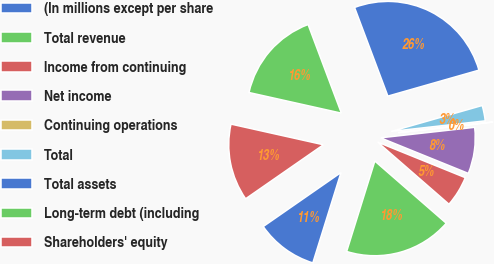Convert chart to OTSL. <chart><loc_0><loc_0><loc_500><loc_500><pie_chart><fcel>(In millions except per share<fcel>Total revenue<fcel>Income from continuing<fcel>Net income<fcel>Continuing operations<fcel>Total<fcel>Total assets<fcel>Long-term debt (including<fcel>Shareholders' equity<nl><fcel>10.53%<fcel>18.41%<fcel>5.27%<fcel>7.9%<fcel>0.01%<fcel>2.64%<fcel>26.3%<fcel>15.78%<fcel>13.16%<nl></chart> 